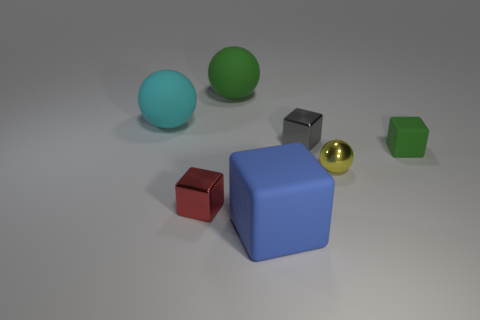Is the size of the rubber object on the right side of the yellow shiny ball the same as the metallic thing in front of the yellow metallic sphere?
Keep it short and to the point. Yes. Is there a matte cube that is behind the metallic thing left of the gray object behind the tiny green matte thing?
Provide a short and direct response. Yes. Is the number of gray metallic objects that are left of the large block less than the number of small objects that are to the right of the small yellow metallic sphere?
Your answer should be very brief. Yes. What is the shape of the small green thing that is the same material as the cyan sphere?
Provide a short and direct response. Cube. What is the size of the metal thing behind the green matte object in front of the metal cube behind the tiny yellow object?
Keep it short and to the point. Small. Are there more cyan matte blocks than small yellow metallic things?
Your answer should be compact. No. Do the tiny thing that is left of the gray shiny object and the matte object that is left of the green ball have the same color?
Your answer should be compact. No. Are the object behind the large cyan rubber sphere and the large block that is left of the small green object made of the same material?
Give a very brief answer. Yes. What number of green things have the same size as the cyan ball?
Your answer should be very brief. 1. Are there fewer large blue blocks than cyan shiny cylinders?
Keep it short and to the point. No. 